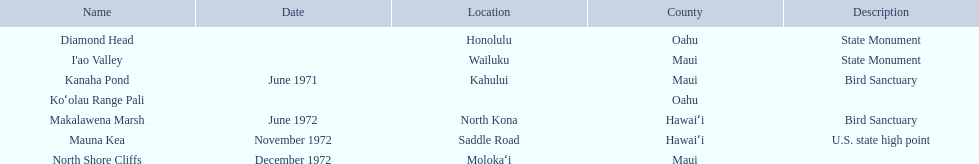What are the natural landmarks in hawaii(national)? Diamond Head, I'ao Valley, Kanaha Pond, Koʻolau Range Pali, Makalawena Marsh, Mauna Kea, North Shore Cliffs. Of these which is described as a u.s state high point? Mauna Kea. 